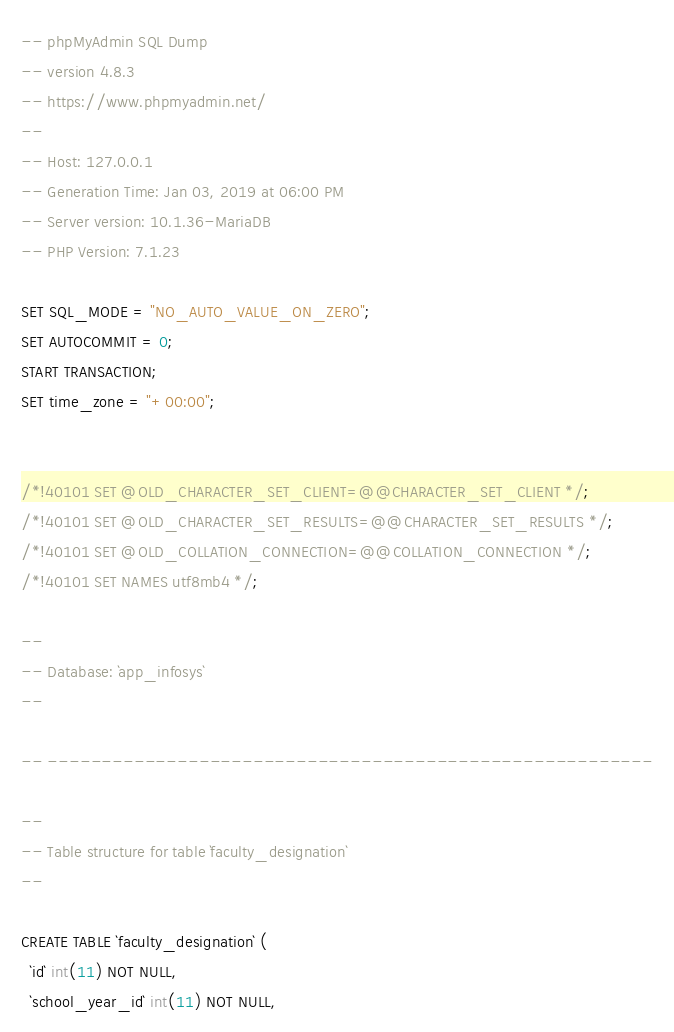Convert code to text. <code><loc_0><loc_0><loc_500><loc_500><_SQL_>-- phpMyAdmin SQL Dump
-- version 4.8.3
-- https://www.phpmyadmin.net/
--
-- Host: 127.0.0.1
-- Generation Time: Jan 03, 2019 at 06:00 PM
-- Server version: 10.1.36-MariaDB
-- PHP Version: 7.1.23

SET SQL_MODE = "NO_AUTO_VALUE_ON_ZERO";
SET AUTOCOMMIT = 0;
START TRANSACTION;
SET time_zone = "+00:00";


/*!40101 SET @OLD_CHARACTER_SET_CLIENT=@@CHARACTER_SET_CLIENT */;
/*!40101 SET @OLD_CHARACTER_SET_RESULTS=@@CHARACTER_SET_RESULTS */;
/*!40101 SET @OLD_COLLATION_CONNECTION=@@COLLATION_CONNECTION */;
/*!40101 SET NAMES utf8mb4 */;

--
-- Database: `app_infosys`
--

-- --------------------------------------------------------

--
-- Table structure for table `faculty_designation`
--

CREATE TABLE `faculty_designation` (
  `id` int(11) NOT NULL,
  `school_year_id` int(11) NOT NULL,</code> 